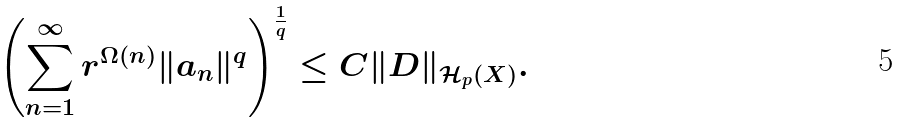Convert formula to latex. <formula><loc_0><loc_0><loc_500><loc_500>\left ( \sum _ { n = 1 } ^ { \infty } r ^ { \Omega ( n ) } \| a _ { n } \| ^ { q } \right ) ^ { \frac { 1 } { q } } \leq C \| D \| _ { \mathcal { H } _ { p } ( X ) } .</formula> 